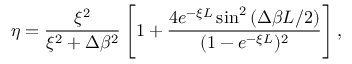<formula> <loc_0><loc_0><loc_500><loc_500>\eta = \frac { \xi ^ { 2 } } { \xi ^ { 2 } + \Delta \beta ^ { 2 } } \left [ 1 + \frac { 4 e ^ { - \xi L } \sin ^ { 2 } { ( \Delta \beta L / 2 ) } } { ( 1 - e ^ { - \xi L } ) ^ { 2 } } \right ] ,</formula> 